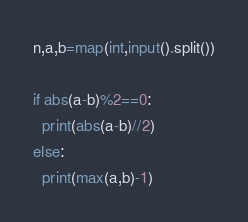<code> <loc_0><loc_0><loc_500><loc_500><_Python_>n,a,b=map(int,input().split())

if abs(a-b)%2==0:
  print(abs(a-b)//2)
else:
  print(max(a,b)-1)</code> 